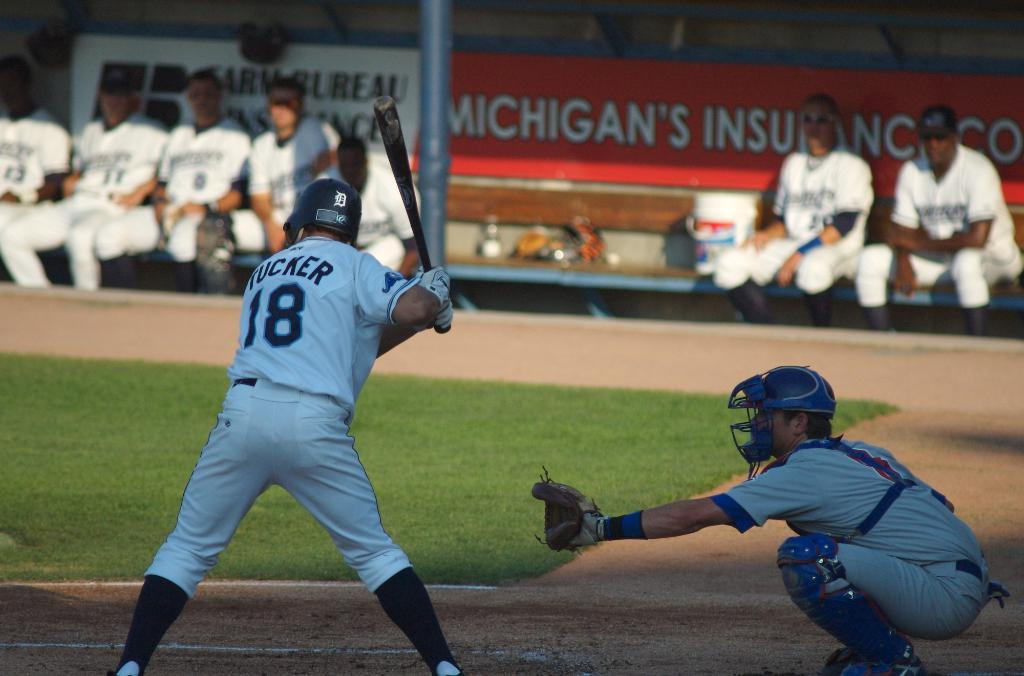<image>
Relay a brief, clear account of the picture shown. A baseball game is underway and the batter's uniform says Tucker 18. 